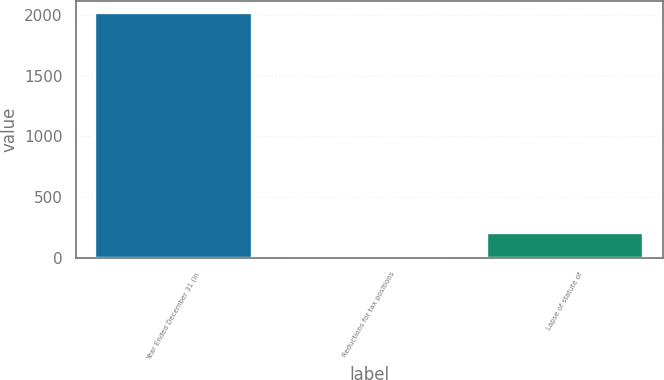Convert chart. <chart><loc_0><loc_0><loc_500><loc_500><bar_chart><fcel>Year Ended December 31 (In<fcel>Reductions for tax positions<fcel>Lapse of statute of<nl><fcel>2015<fcel>3<fcel>204.2<nl></chart> 